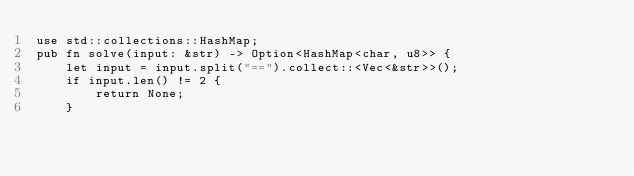<code> <loc_0><loc_0><loc_500><loc_500><_Rust_>use std::collections::HashMap;
pub fn solve(input: &str) -> Option<HashMap<char, u8>> {
    let input = input.split("==").collect::<Vec<&str>>();
    if input.len() != 2 {
        return None;
    }</code> 